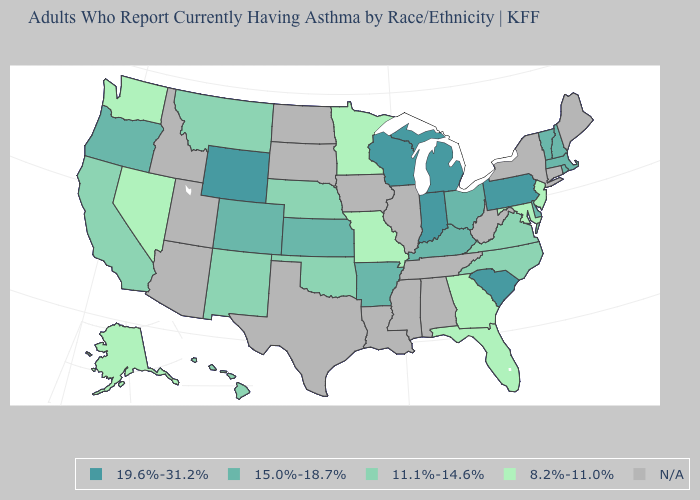Does the map have missing data?
Short answer required. Yes. Name the states that have a value in the range 15.0%-18.7%?
Answer briefly. Arkansas, Colorado, Delaware, Kansas, Kentucky, Massachusetts, New Hampshire, Ohio, Oregon, Rhode Island, Vermont. What is the value of New York?
Short answer required. N/A. Which states have the highest value in the USA?
Keep it brief. Indiana, Michigan, Pennsylvania, South Carolina, Wisconsin, Wyoming. What is the value of Georgia?
Be succinct. 8.2%-11.0%. Name the states that have a value in the range 19.6%-31.2%?
Be succinct. Indiana, Michigan, Pennsylvania, South Carolina, Wisconsin, Wyoming. Does South Carolina have the highest value in the USA?
Keep it brief. Yes. What is the lowest value in the West?
Concise answer only. 8.2%-11.0%. Which states have the lowest value in the MidWest?
Concise answer only. Minnesota, Missouri. Name the states that have a value in the range 15.0%-18.7%?
Answer briefly. Arkansas, Colorado, Delaware, Kansas, Kentucky, Massachusetts, New Hampshire, Ohio, Oregon, Rhode Island, Vermont. What is the lowest value in states that border Michigan?
Quick response, please. 15.0%-18.7%. Among the states that border Kansas , which have the highest value?
Answer briefly. Colorado. Name the states that have a value in the range 19.6%-31.2%?
Answer briefly. Indiana, Michigan, Pennsylvania, South Carolina, Wisconsin, Wyoming. What is the value of Connecticut?
Give a very brief answer. N/A. 